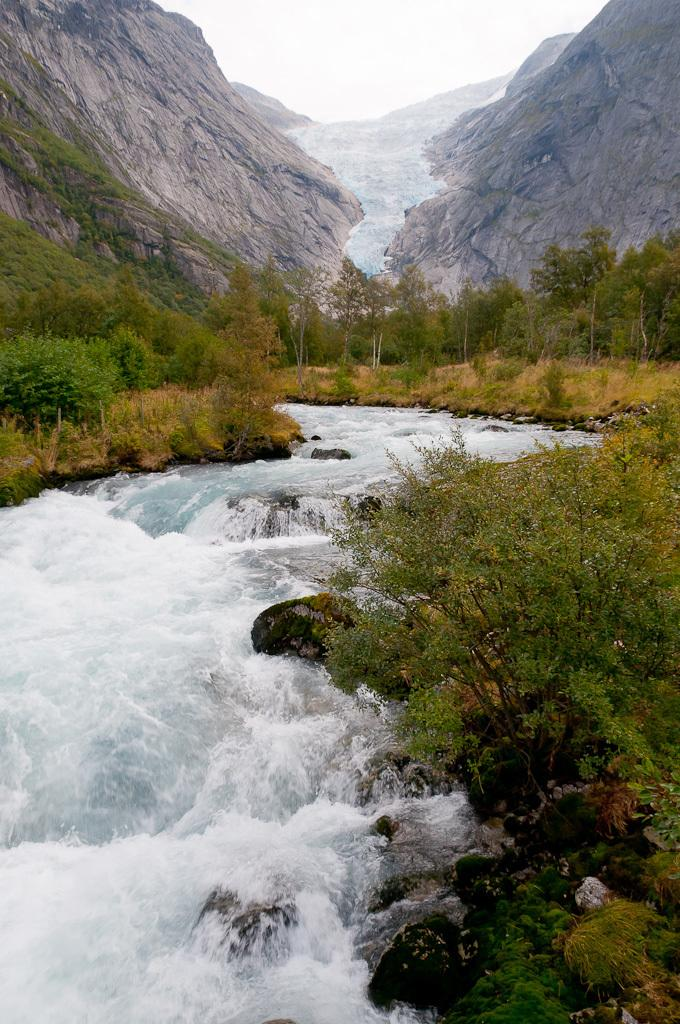What type of landscape is depicted in the image? The image contains a valley. What can be observed in the valley? There is greenery in the image. What other geographical features are present in the image? There are mountains in the image. Where is the fire hydrant located in the image? There is no fire hydrant present in the image. What is the best route to take to reach the top of the mountain in the image? The image does not provide enough information to determine the best route to reach the top of the mountain. 